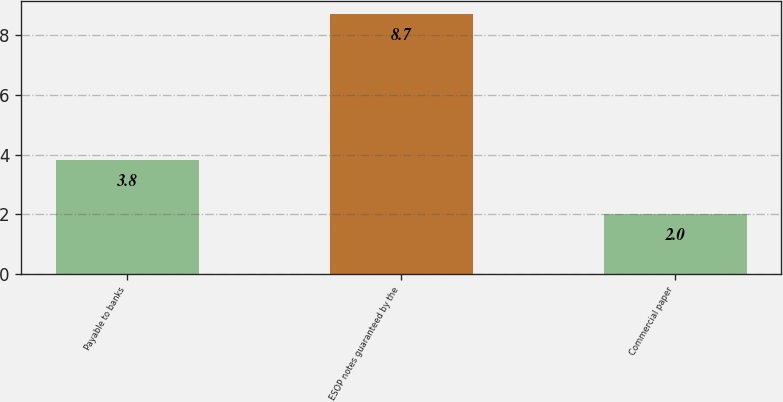Convert chart to OTSL. <chart><loc_0><loc_0><loc_500><loc_500><bar_chart><fcel>Payable to banks<fcel>ESOP notes guaranteed by the<fcel>Commercial paper<nl><fcel>3.8<fcel>8.7<fcel>2<nl></chart> 